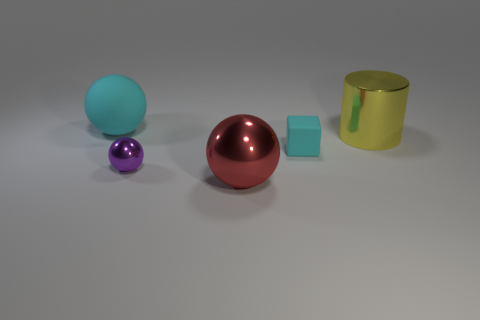Can you describe the colors and shapes of the objects presented? Certainly! The image displays objects with a variety of colors and shapes. From left to right, there's a turquoise sphere, a small lavender sphere, a larger copper-colored sphere, a slate blue cube, and a yellow metallic cylinder. 